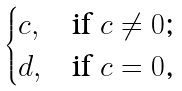Convert formula to latex. <formula><loc_0><loc_0><loc_500><loc_500>\begin{cases} c , & \text {if $c\neq 0$;} \\ d , & \text {if $c=0$,} \end{cases}</formula> 